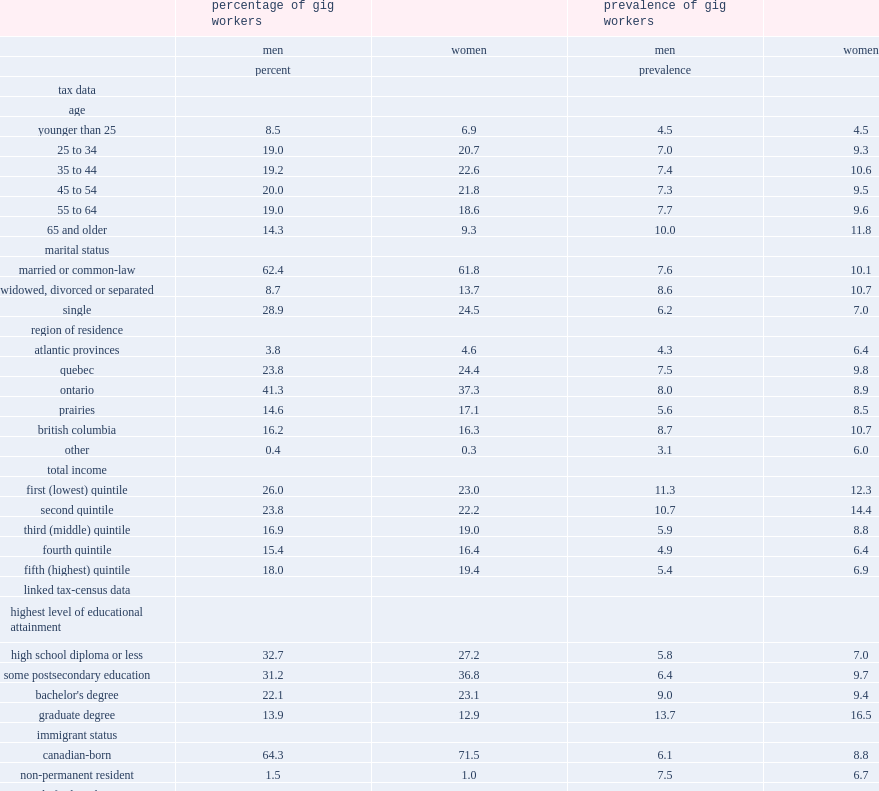Which age group has the highest prevalence of gig workers? 65 and older. What is the percentage of men gig workers who were married or cohabited in 2016? 62.4. What is the percentage of male git workers who were single? 28.9. What is the percentage of female workers who were single? 24.5. How much is the ratio of male gig workers' prevalence in the top income quntile to male gig workers' prevalence in the bottom income quntile? 0.477876. How much is the ratio of female gig workers' prevalence in the top income quntile to male gig workers' prevalence in the bottom income quntile? 0.560976. 